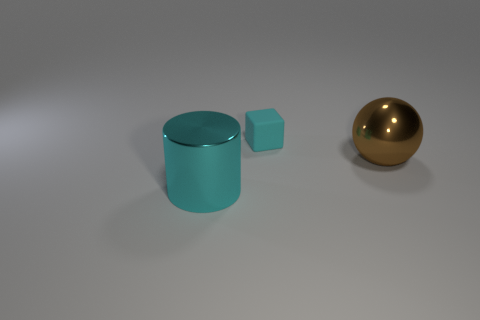There is a big object on the left side of the brown thing; is its shape the same as the large thing that is right of the small object?
Your answer should be compact. No. What is the size of the rubber block that is the same color as the large cylinder?
Your response must be concise. Small. What is the size of the brown ball that is the same material as the big cylinder?
Your answer should be compact. Large. What number of objects are large balls or blocks?
Offer a very short reply. 2. The tiny thing is what shape?
Ensure brevity in your answer.  Cube. Is there any other thing that is made of the same material as the tiny block?
Offer a very short reply. No. There is a metal thing that is right of the cyan thing right of the large cyan metallic cylinder; what is its size?
Offer a terse response. Large. Is the number of large shiny things on the left side of the big brown metal ball the same as the number of green cubes?
Ensure brevity in your answer.  No. What number of other objects are the same color as the big sphere?
Ensure brevity in your answer.  0. Is the number of cyan matte objects in front of the big cyan metallic cylinder less than the number of big purple blocks?
Provide a succinct answer. No. 